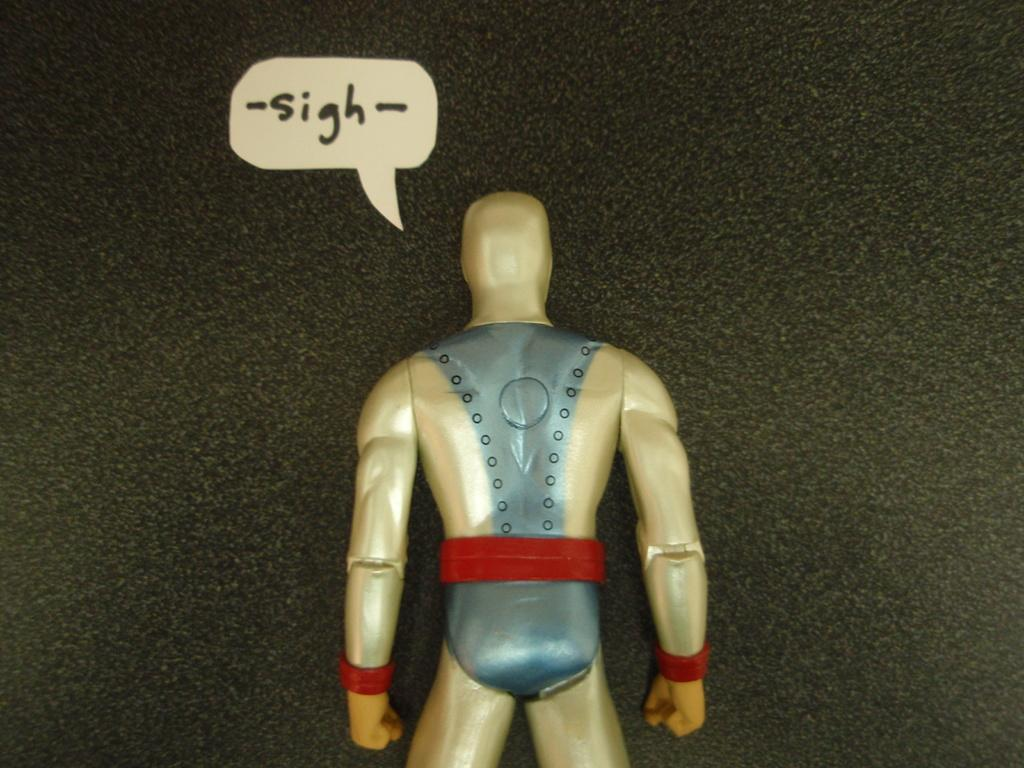What object can be seen in the image? There is a toy in the image. What else is present in the image besides the toy? There is text above the toy. What type of current can be seen flowing through the toy in the image? There is no current visible in the image, as it features a toy and text. 